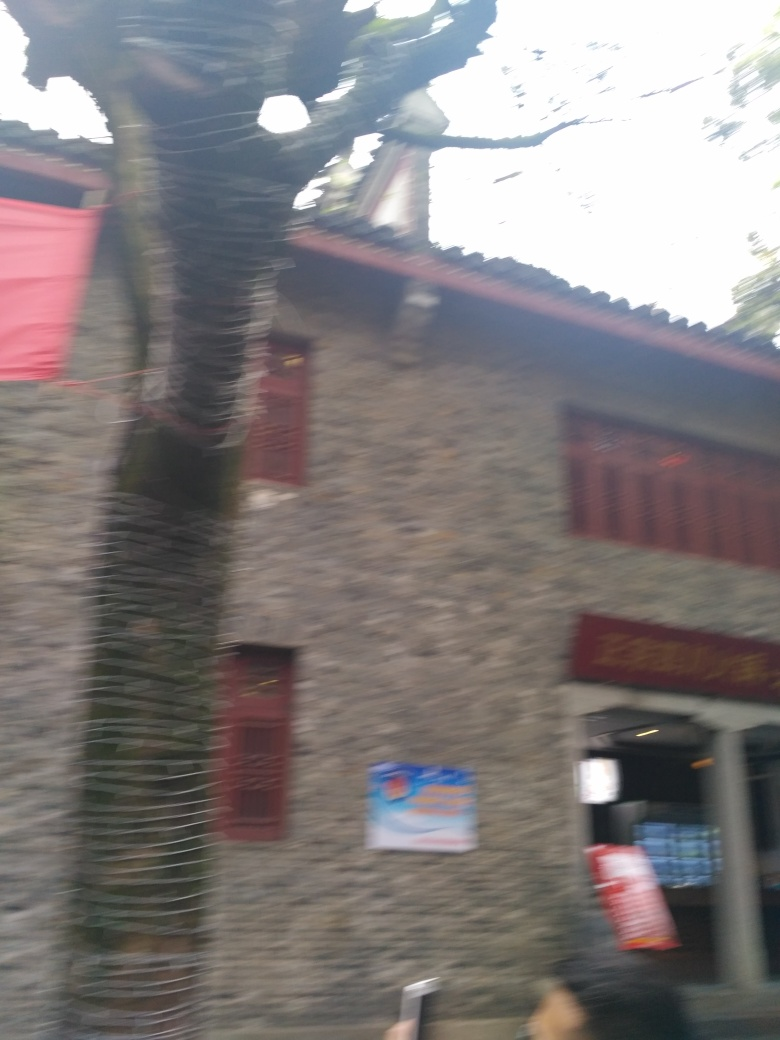Can you tell what time of day might it be in this photo? Due to the overall brightness and light distribution, despite the image's quality issues, it appears to be daytime. However, the exact time cannot be determined from the given information. 